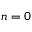Convert formula to latex. <formula><loc_0><loc_0><loc_500><loc_500>n = 0</formula> 